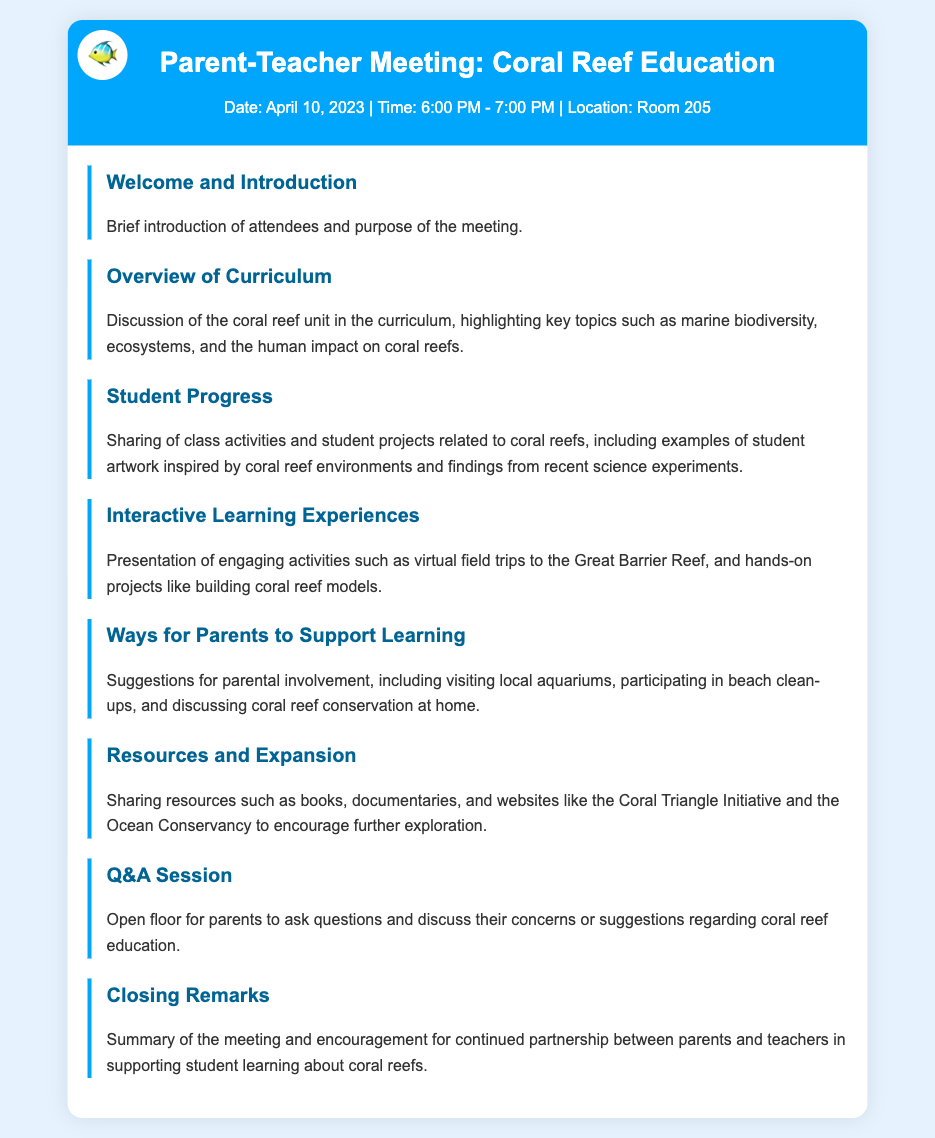What is the date of the meeting? The date of the meeting is mentioned in the meeting info section.
Answer: April 10, 2023 What time does the meeting start? The start time is provided in the meeting info section.
Answer: 6:00 PM What is the location of the meeting? The location is specified in the meeting info section.
Answer: Room 205 What is one of the topics discussed in the Overview of Curriculum? This is found in the agenda item for Overview of Curriculum.
Answer: Marine biodiversity What engaging activity involves virtual travel? The term is referenced in the agenda item about Interactive Learning Experiences.
Answer: Virtual field trips Name one way parents can support learning. This is detailed in the Ways for Parents to Support Learning section.
Answer: Beach clean-ups What type of session is included for parents to ask questions? This is indicated in the agenda structure.
Answer: Q&A Session What is the purpose of the Closing Remarks? The purpose is summarized in the Closing Remarks section of the agenda.
Answer: Summary of the meeting 